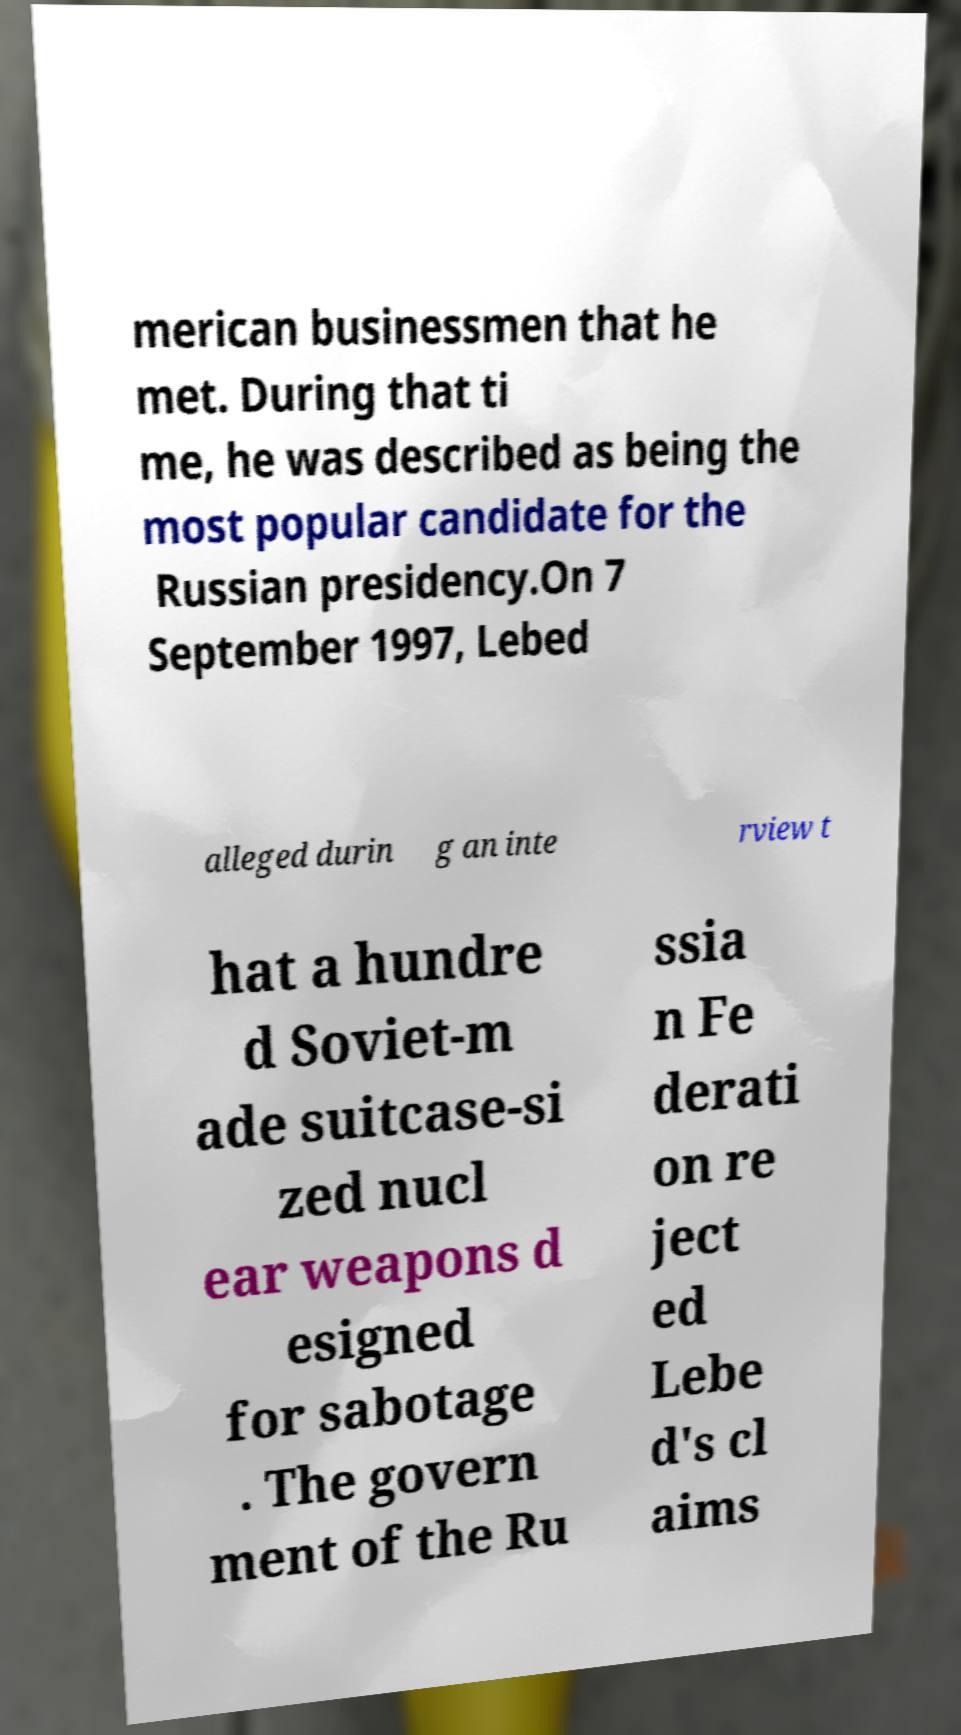I need the written content from this picture converted into text. Can you do that? merican businessmen that he met. During that ti me, he was described as being the most popular candidate for the Russian presidency.On 7 September 1997, Lebed alleged durin g an inte rview t hat a hundre d Soviet-m ade suitcase-si zed nucl ear weapons d esigned for sabotage . The govern ment of the Ru ssia n Fe derati on re ject ed Lebe d's cl aims 